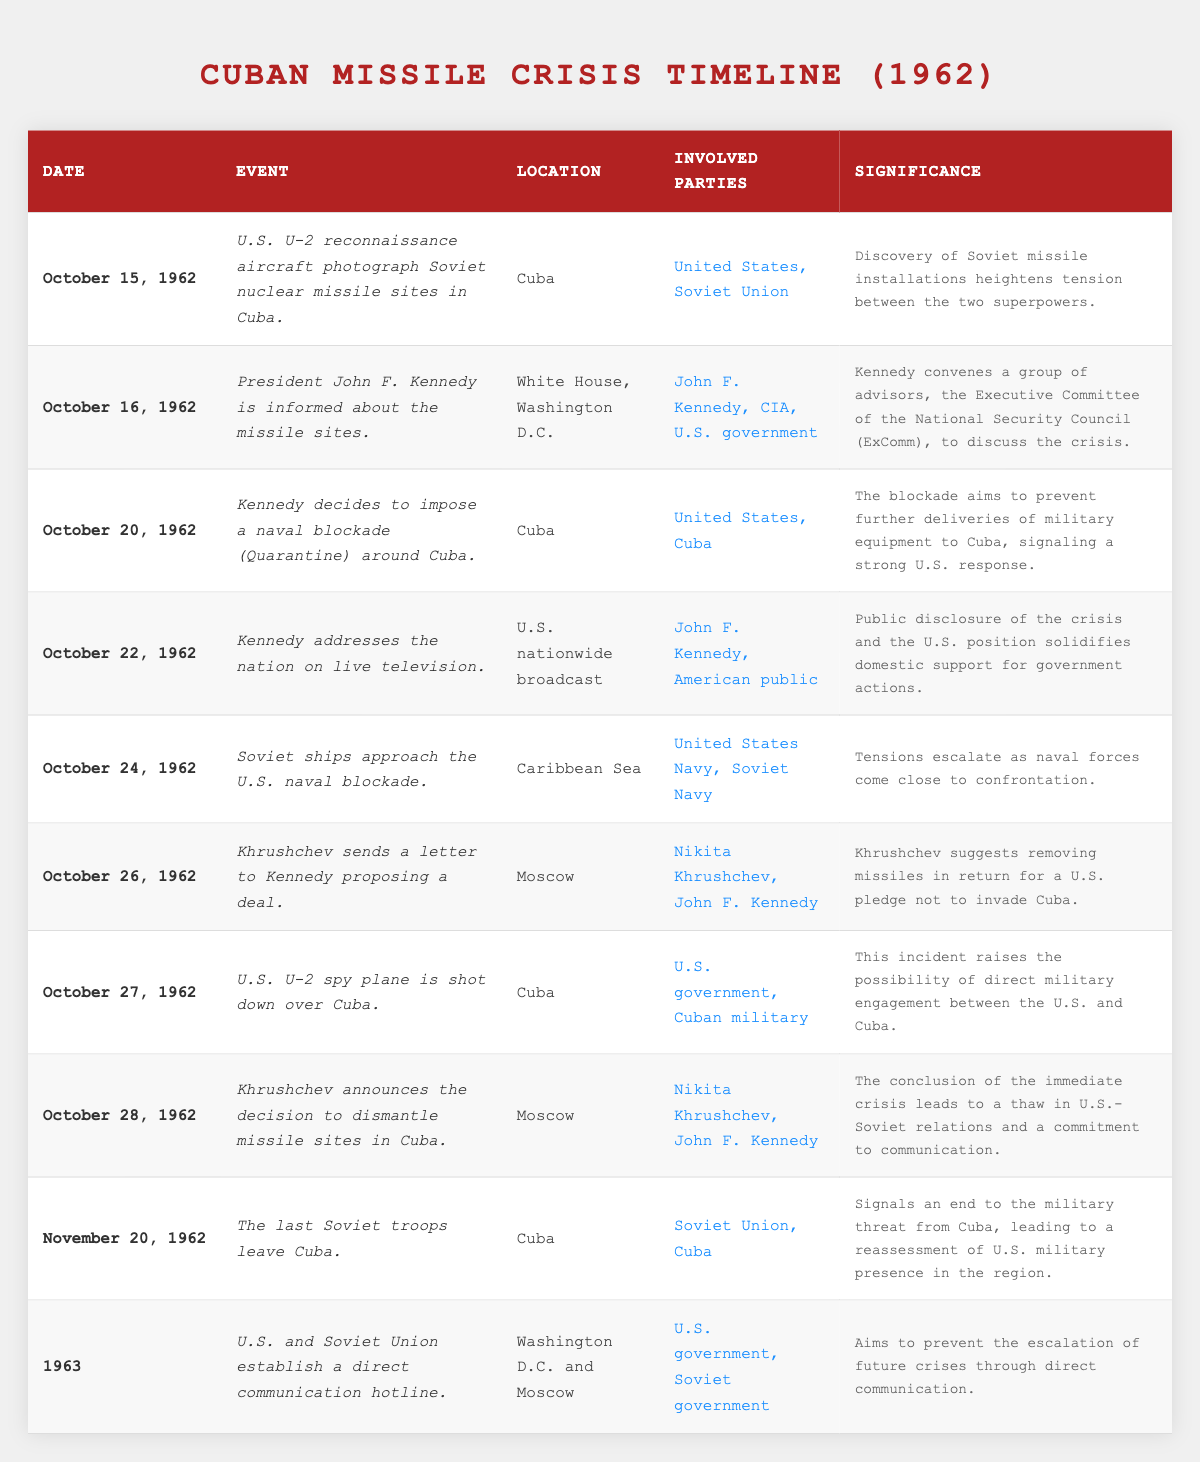What date did JFK inform the nation about the missile crisis? According to the table, JFK addressed the nation on live television on October 22, 1962.
Answer: October 22, 1962 How many days passed between the first U.S. U-2 reconnaissance flight and the announcement of the blockade? The first reconnaissance flight was on October 15, 1962, and the blockade was announced on October 20, 1962. Counting the days, 20 - 15 = 5 days.
Answer: 5 days What event occurred immediately after the Soviet ships approached the naval blockade? The next event listed was Khrushchev sending a letter to Kennedy proposing a deal on October 26, 1962, following the Soviet ships' approach on October 24, 1962.
Answer: Khrushchev sent a letter proposing a deal On which date did the last Soviet troops leave Cuba? The table lists November 20, 1962, as the date when the last Soviet troops left Cuba.
Answer: November 20, 1962 Was a direct communication hotline established between the U.S. and the Soviet Union after the crisis? Yes, according to the table, a direct communication hotline was established in 1963.
Answer: Yes How many significant events took place in October 1962? By counting the events listed for October 1962 in the table, there are 7 entries from October 15 to October 28, 1962.
Answer: 7 significant events What was the significance of the U-2 spy plane being shot down over Cuba? The significance noted in the table states it raised the possibility of direct military engagement between the U.S. and Cuba.
Answer: Raised possibility of military engagement What deal did Khrushchev propose in his letter to JFK? The letter suggested removing missiles in Cuba in exchange for a U.S. pledge not to invade Cuba, as noted in the significance.
Answer: Removal of missiles for a non-invasion pledge How did Kennedy's address on October 22 affect domestic support? The significance states that public disclosure of the crisis solidified domestic support for government actions.
Answer: Solidified domestic support Which two countries were involved in the establishment of the direct communication hotline? The table indicates that the U.S. government and Soviet government were the two involved.
Answer: U.S. and Soviet Union What followed immediately after Khrushchev announced the dismantling of missile sites? The next event recorded is the departure of the last Soviet troops from Cuba on November 20, 1962, indicating a resolution to military tensions.
Answer: Departure of last Soviet troops from Cuba 